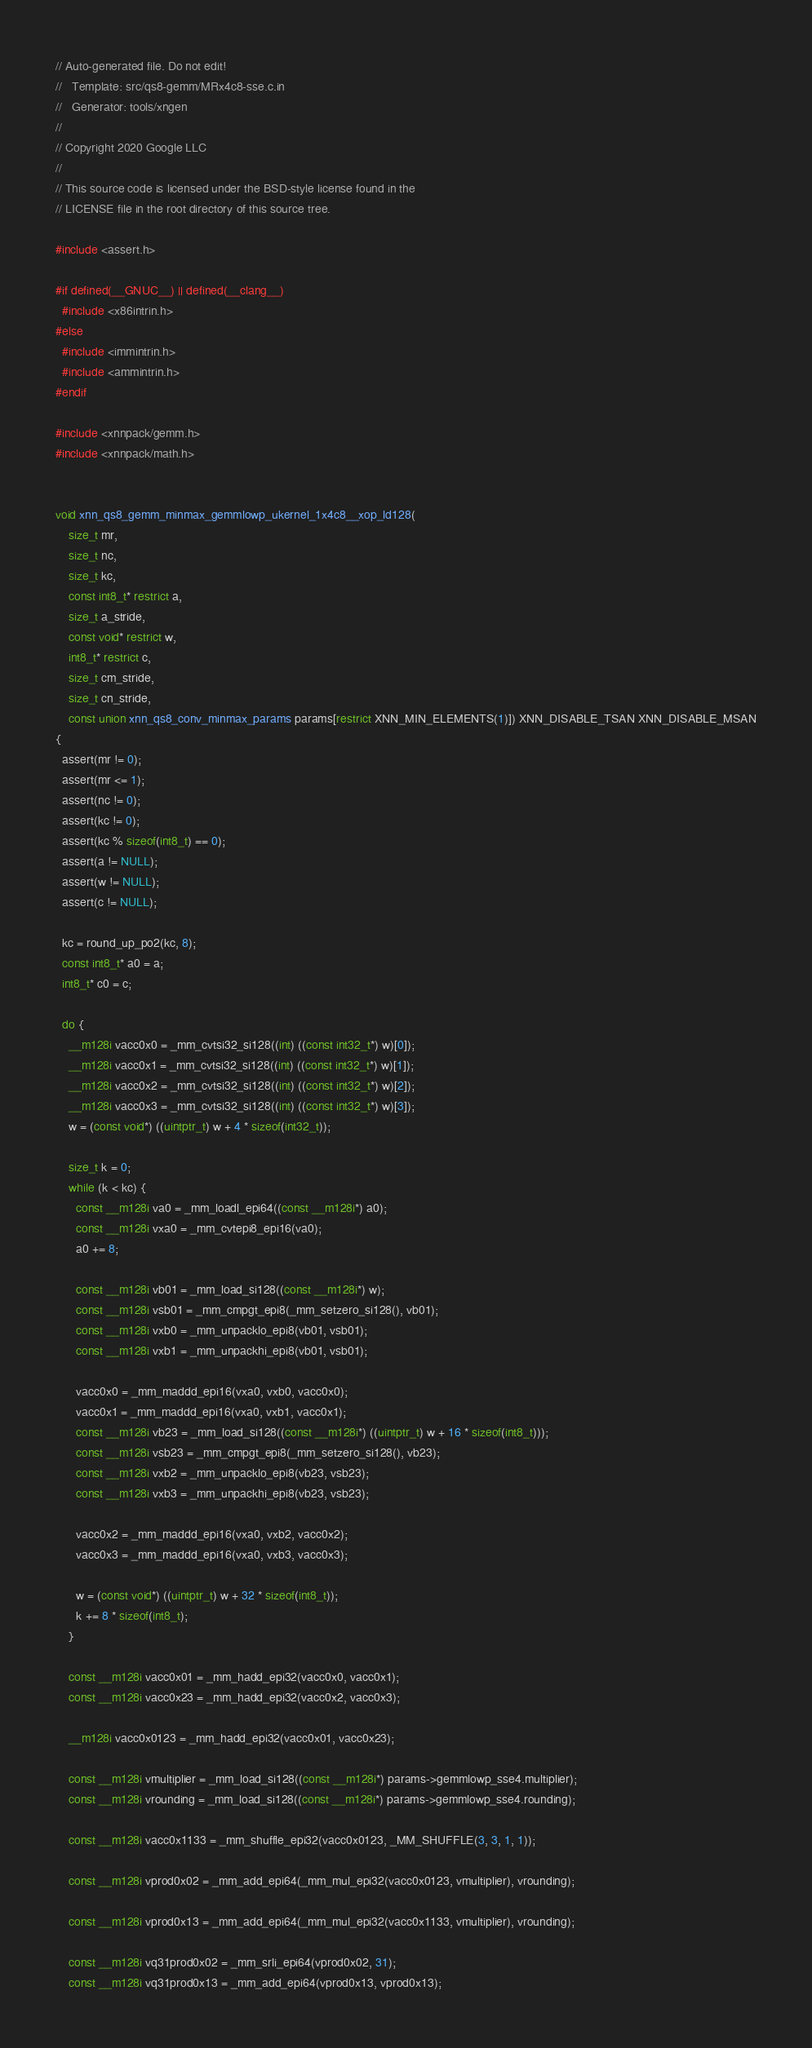<code> <loc_0><loc_0><loc_500><loc_500><_C_>// Auto-generated file. Do not edit!
//   Template: src/qs8-gemm/MRx4c8-sse.c.in
//   Generator: tools/xngen
//
// Copyright 2020 Google LLC
//
// This source code is licensed under the BSD-style license found in the
// LICENSE file in the root directory of this source tree.

#include <assert.h>

#if defined(__GNUC__) || defined(__clang__)
  #include <x86intrin.h>
#else
  #include <immintrin.h>
  #include <ammintrin.h>
#endif

#include <xnnpack/gemm.h>
#include <xnnpack/math.h>


void xnn_qs8_gemm_minmax_gemmlowp_ukernel_1x4c8__xop_ld128(
    size_t mr,
    size_t nc,
    size_t kc,
    const int8_t* restrict a,
    size_t a_stride,
    const void* restrict w,
    int8_t* restrict c,
    size_t cm_stride,
    size_t cn_stride,
    const union xnn_qs8_conv_minmax_params params[restrict XNN_MIN_ELEMENTS(1)]) XNN_DISABLE_TSAN XNN_DISABLE_MSAN
{
  assert(mr != 0);
  assert(mr <= 1);
  assert(nc != 0);
  assert(kc != 0);
  assert(kc % sizeof(int8_t) == 0);
  assert(a != NULL);
  assert(w != NULL);
  assert(c != NULL);

  kc = round_up_po2(kc, 8);
  const int8_t* a0 = a;
  int8_t* c0 = c;

  do {
    __m128i vacc0x0 = _mm_cvtsi32_si128((int) ((const int32_t*) w)[0]);
    __m128i vacc0x1 = _mm_cvtsi32_si128((int) ((const int32_t*) w)[1]);
    __m128i vacc0x2 = _mm_cvtsi32_si128((int) ((const int32_t*) w)[2]);
    __m128i vacc0x3 = _mm_cvtsi32_si128((int) ((const int32_t*) w)[3]);
    w = (const void*) ((uintptr_t) w + 4 * sizeof(int32_t));

    size_t k = 0;
    while (k < kc) {
      const __m128i va0 = _mm_loadl_epi64((const __m128i*) a0);
      const __m128i vxa0 = _mm_cvtepi8_epi16(va0);
      a0 += 8;

      const __m128i vb01 = _mm_load_si128((const __m128i*) w);
      const __m128i vsb01 = _mm_cmpgt_epi8(_mm_setzero_si128(), vb01);
      const __m128i vxb0 = _mm_unpacklo_epi8(vb01, vsb01);
      const __m128i vxb1 = _mm_unpackhi_epi8(vb01, vsb01);

      vacc0x0 = _mm_maddd_epi16(vxa0, vxb0, vacc0x0);
      vacc0x1 = _mm_maddd_epi16(vxa0, vxb1, vacc0x1);
      const __m128i vb23 = _mm_load_si128((const __m128i*) ((uintptr_t) w + 16 * sizeof(int8_t)));
      const __m128i vsb23 = _mm_cmpgt_epi8(_mm_setzero_si128(), vb23);
      const __m128i vxb2 = _mm_unpacklo_epi8(vb23, vsb23);
      const __m128i vxb3 = _mm_unpackhi_epi8(vb23, vsb23);

      vacc0x2 = _mm_maddd_epi16(vxa0, vxb2, vacc0x2);
      vacc0x3 = _mm_maddd_epi16(vxa0, vxb3, vacc0x3);

      w = (const void*) ((uintptr_t) w + 32 * sizeof(int8_t));
      k += 8 * sizeof(int8_t);
    }

    const __m128i vacc0x01 = _mm_hadd_epi32(vacc0x0, vacc0x1);
    const __m128i vacc0x23 = _mm_hadd_epi32(vacc0x2, vacc0x3);

    __m128i vacc0x0123 = _mm_hadd_epi32(vacc0x01, vacc0x23);

    const __m128i vmultiplier = _mm_load_si128((const __m128i*) params->gemmlowp_sse4.multiplier);
    const __m128i vrounding = _mm_load_si128((const __m128i*) params->gemmlowp_sse4.rounding);

    const __m128i vacc0x1133 = _mm_shuffle_epi32(vacc0x0123, _MM_SHUFFLE(3, 3, 1, 1));

    const __m128i vprod0x02 = _mm_add_epi64(_mm_mul_epi32(vacc0x0123, vmultiplier), vrounding);

    const __m128i vprod0x13 = _mm_add_epi64(_mm_mul_epi32(vacc0x1133, vmultiplier), vrounding);

    const __m128i vq31prod0x02 = _mm_srli_epi64(vprod0x02, 31);
    const __m128i vq31prod0x13 = _mm_add_epi64(vprod0x13, vprod0x13);
</code> 